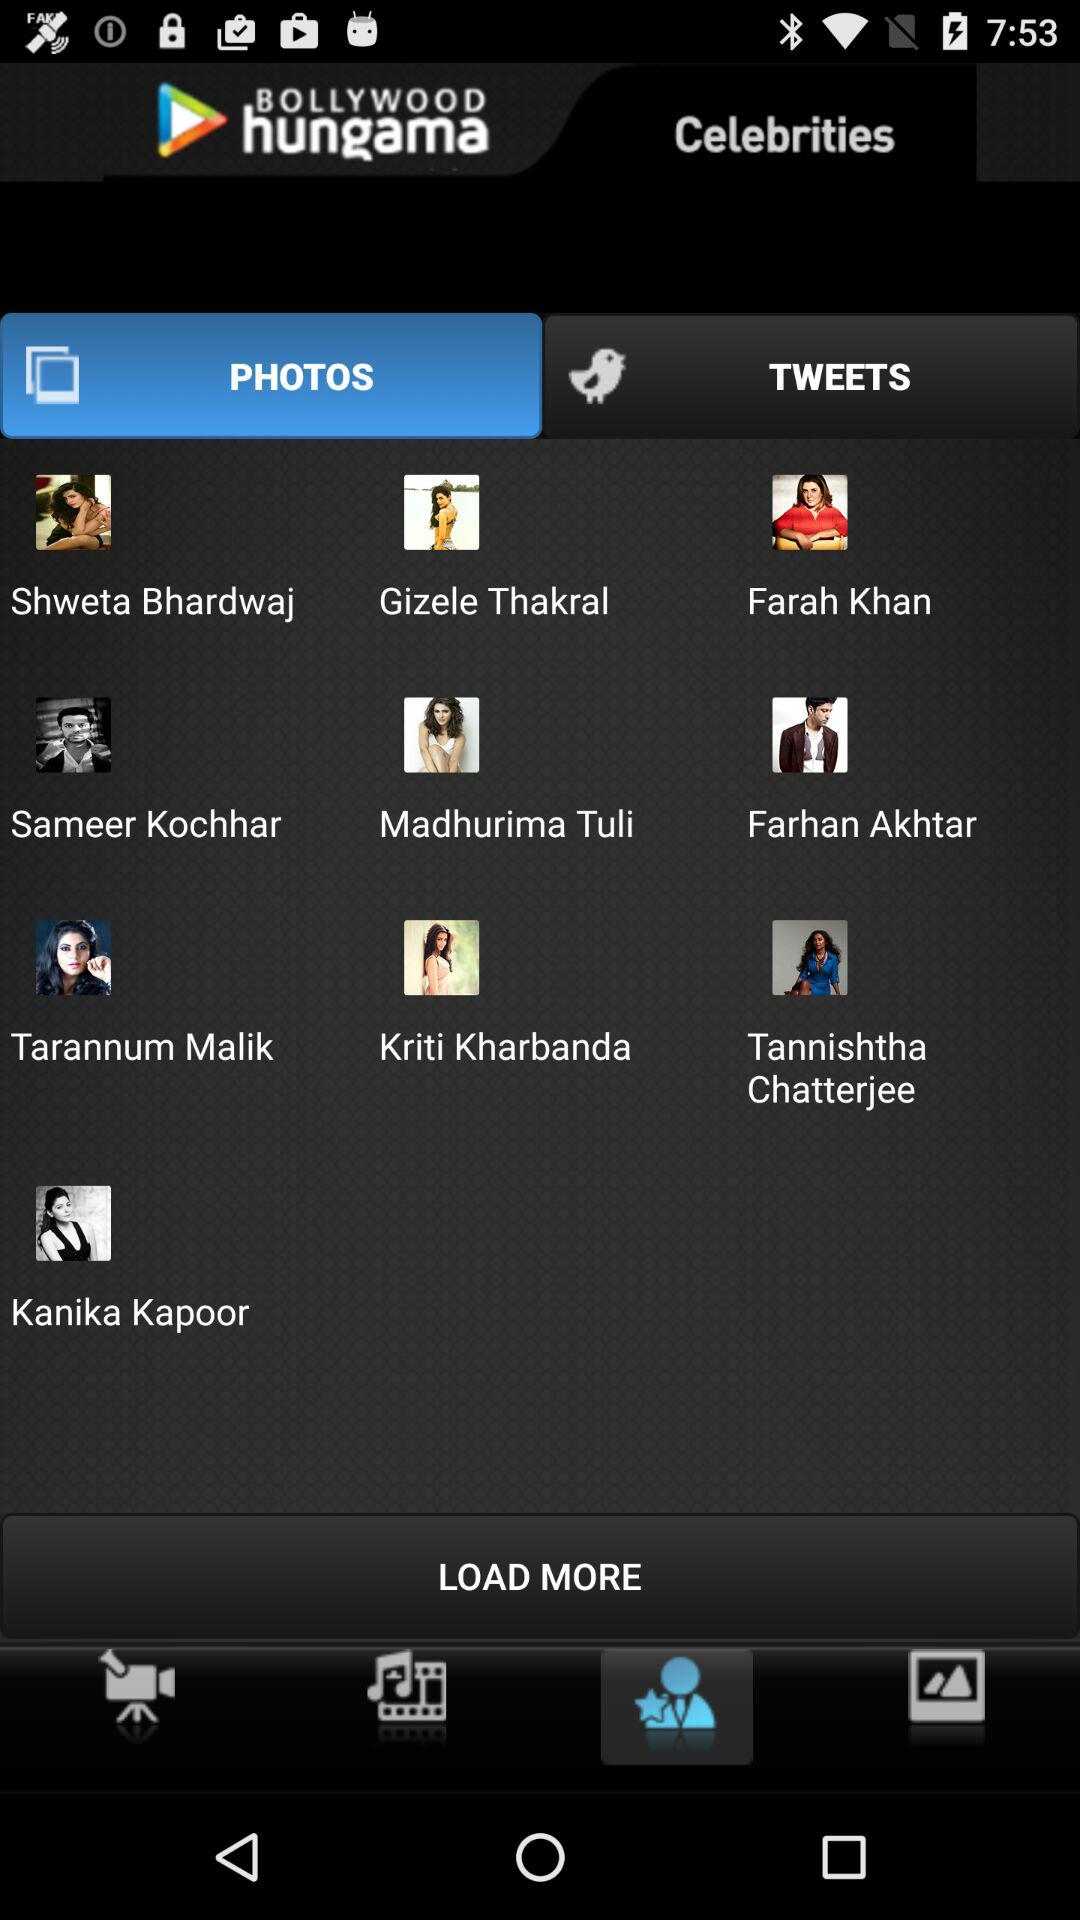What are the different celebrity names available in the "PHOTOS"? The different celebrity names are Shweta Bhardwaj, Gizele Thakral, Farah Khan, Sameer Kochhar, Madhurima Tuli, Farhan Akhtar, Tarannum Malik, Kriti Kharbanda, Tannishtha Chatterjee and Kanika Kapoor. 